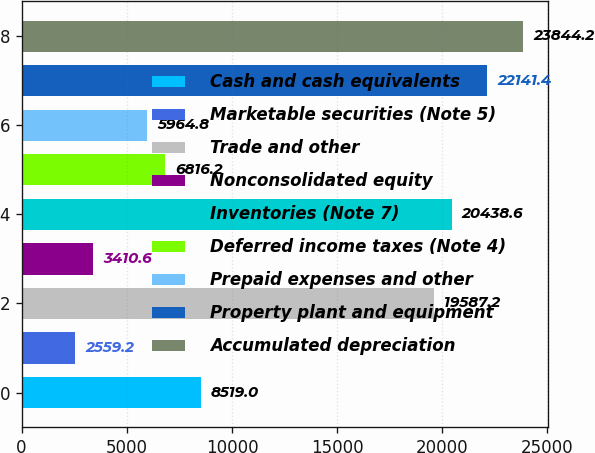Convert chart. <chart><loc_0><loc_0><loc_500><loc_500><bar_chart><fcel>Cash and cash equivalents<fcel>Marketable securities (Note 5)<fcel>Trade and other<fcel>Nonconsolidated equity<fcel>Inventories (Note 7)<fcel>Deferred income taxes (Note 4)<fcel>Prepaid expenses and other<fcel>Property plant and equipment<fcel>Accumulated depreciation<nl><fcel>8519<fcel>2559.2<fcel>19587.2<fcel>3410.6<fcel>20438.6<fcel>6816.2<fcel>5964.8<fcel>22141.4<fcel>23844.2<nl></chart> 